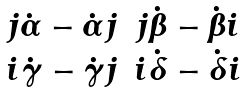<formula> <loc_0><loc_0><loc_500><loc_500>\begin{matrix} j \dot { \alpha } - \dot { \alpha } j & j \dot { \beta } - \dot { \beta } i \\ i \dot { \gamma } - \dot { \gamma } j & i \dot { \delta } - \dot { \delta } i \end{matrix}</formula> 